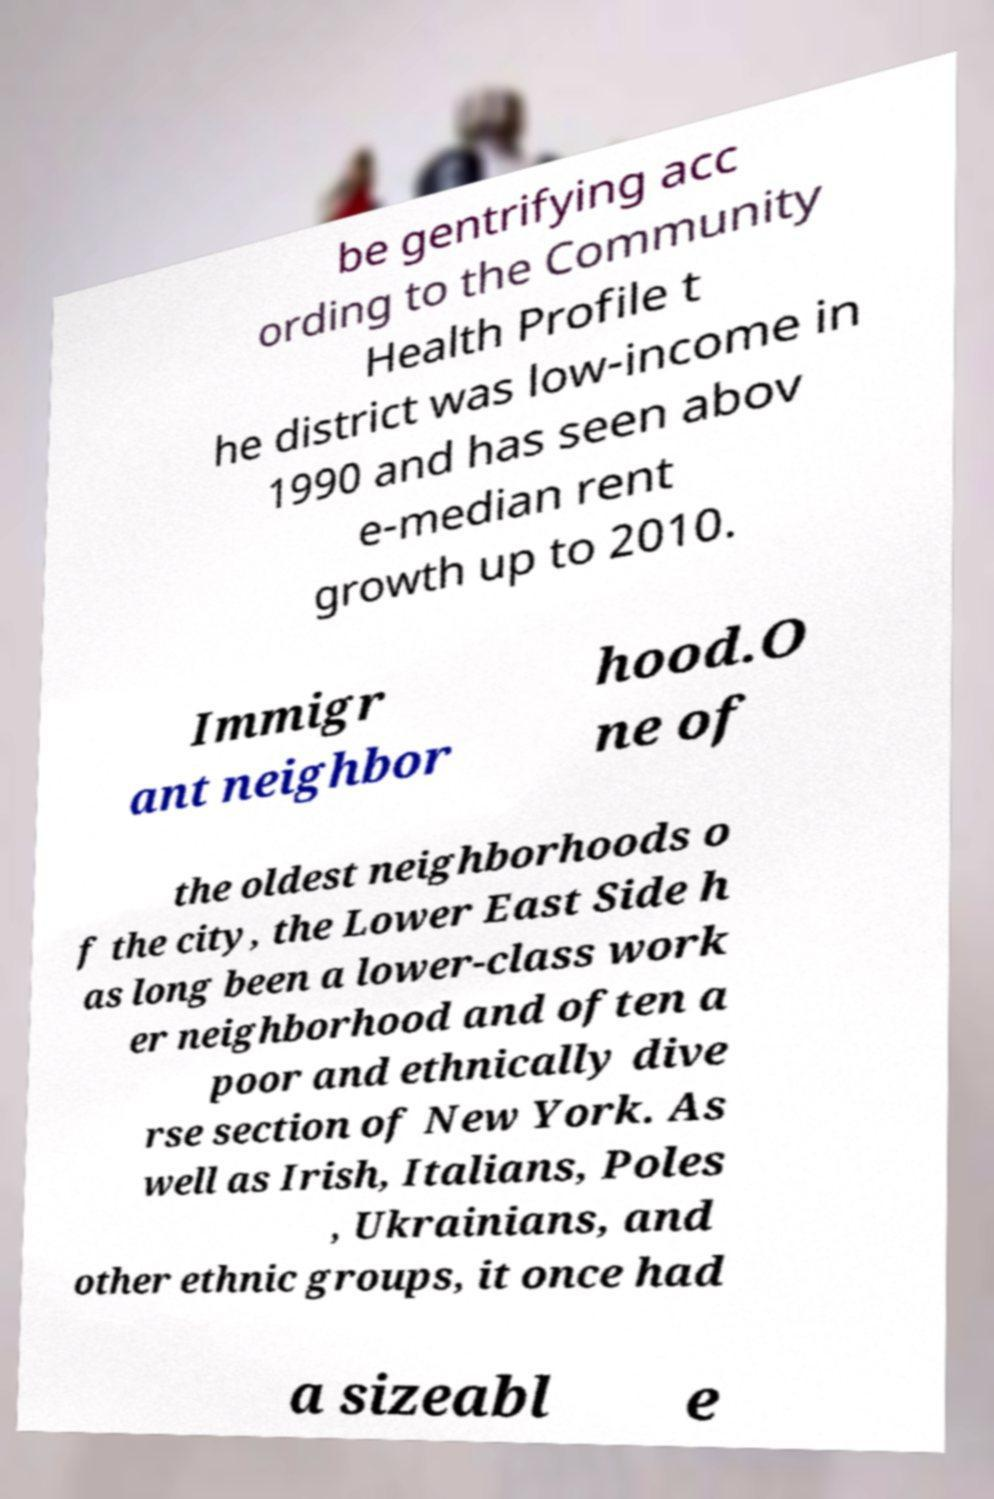Can you accurately transcribe the text from the provided image for me? be gentrifying acc ording to the Community Health Profile t he district was low-income in 1990 and has seen abov e-median rent growth up to 2010. Immigr ant neighbor hood.O ne of the oldest neighborhoods o f the city, the Lower East Side h as long been a lower-class work er neighborhood and often a poor and ethnically dive rse section of New York. As well as Irish, Italians, Poles , Ukrainians, and other ethnic groups, it once had a sizeabl e 